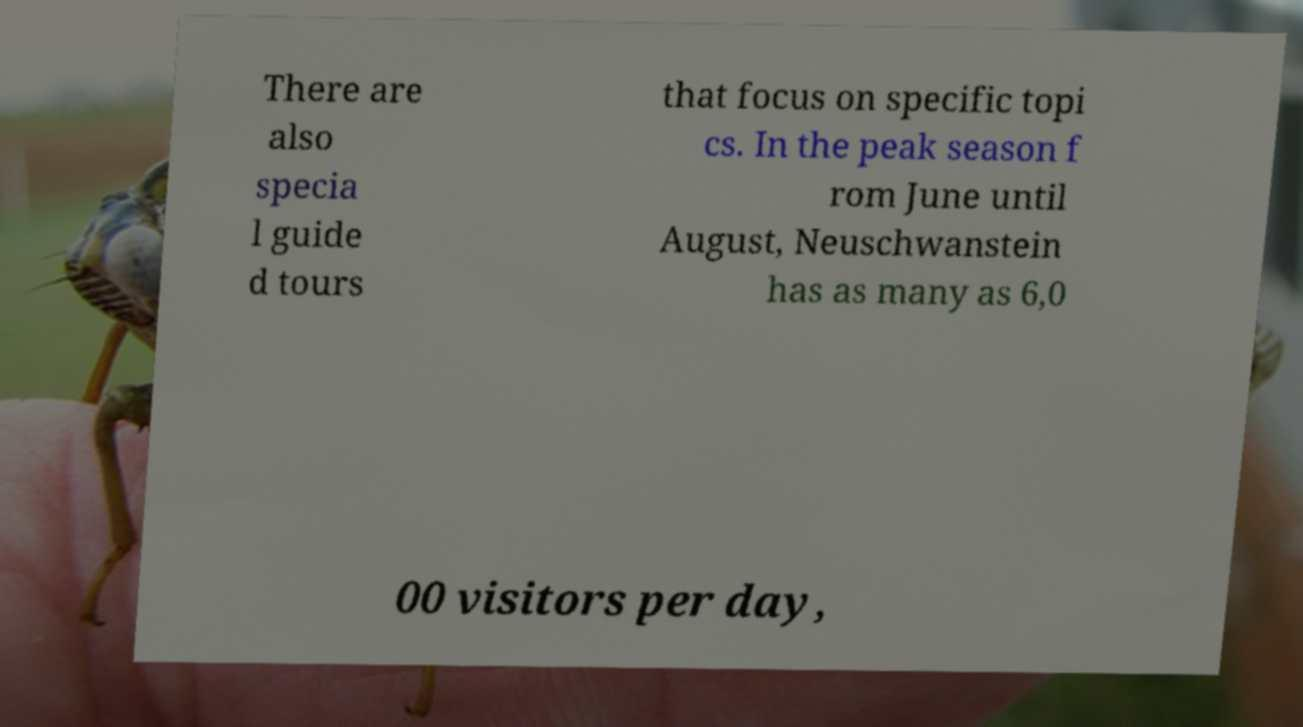There's text embedded in this image that I need extracted. Can you transcribe it verbatim? There are also specia l guide d tours that focus on specific topi cs. In the peak season f rom June until August, Neuschwanstein has as many as 6,0 00 visitors per day, 